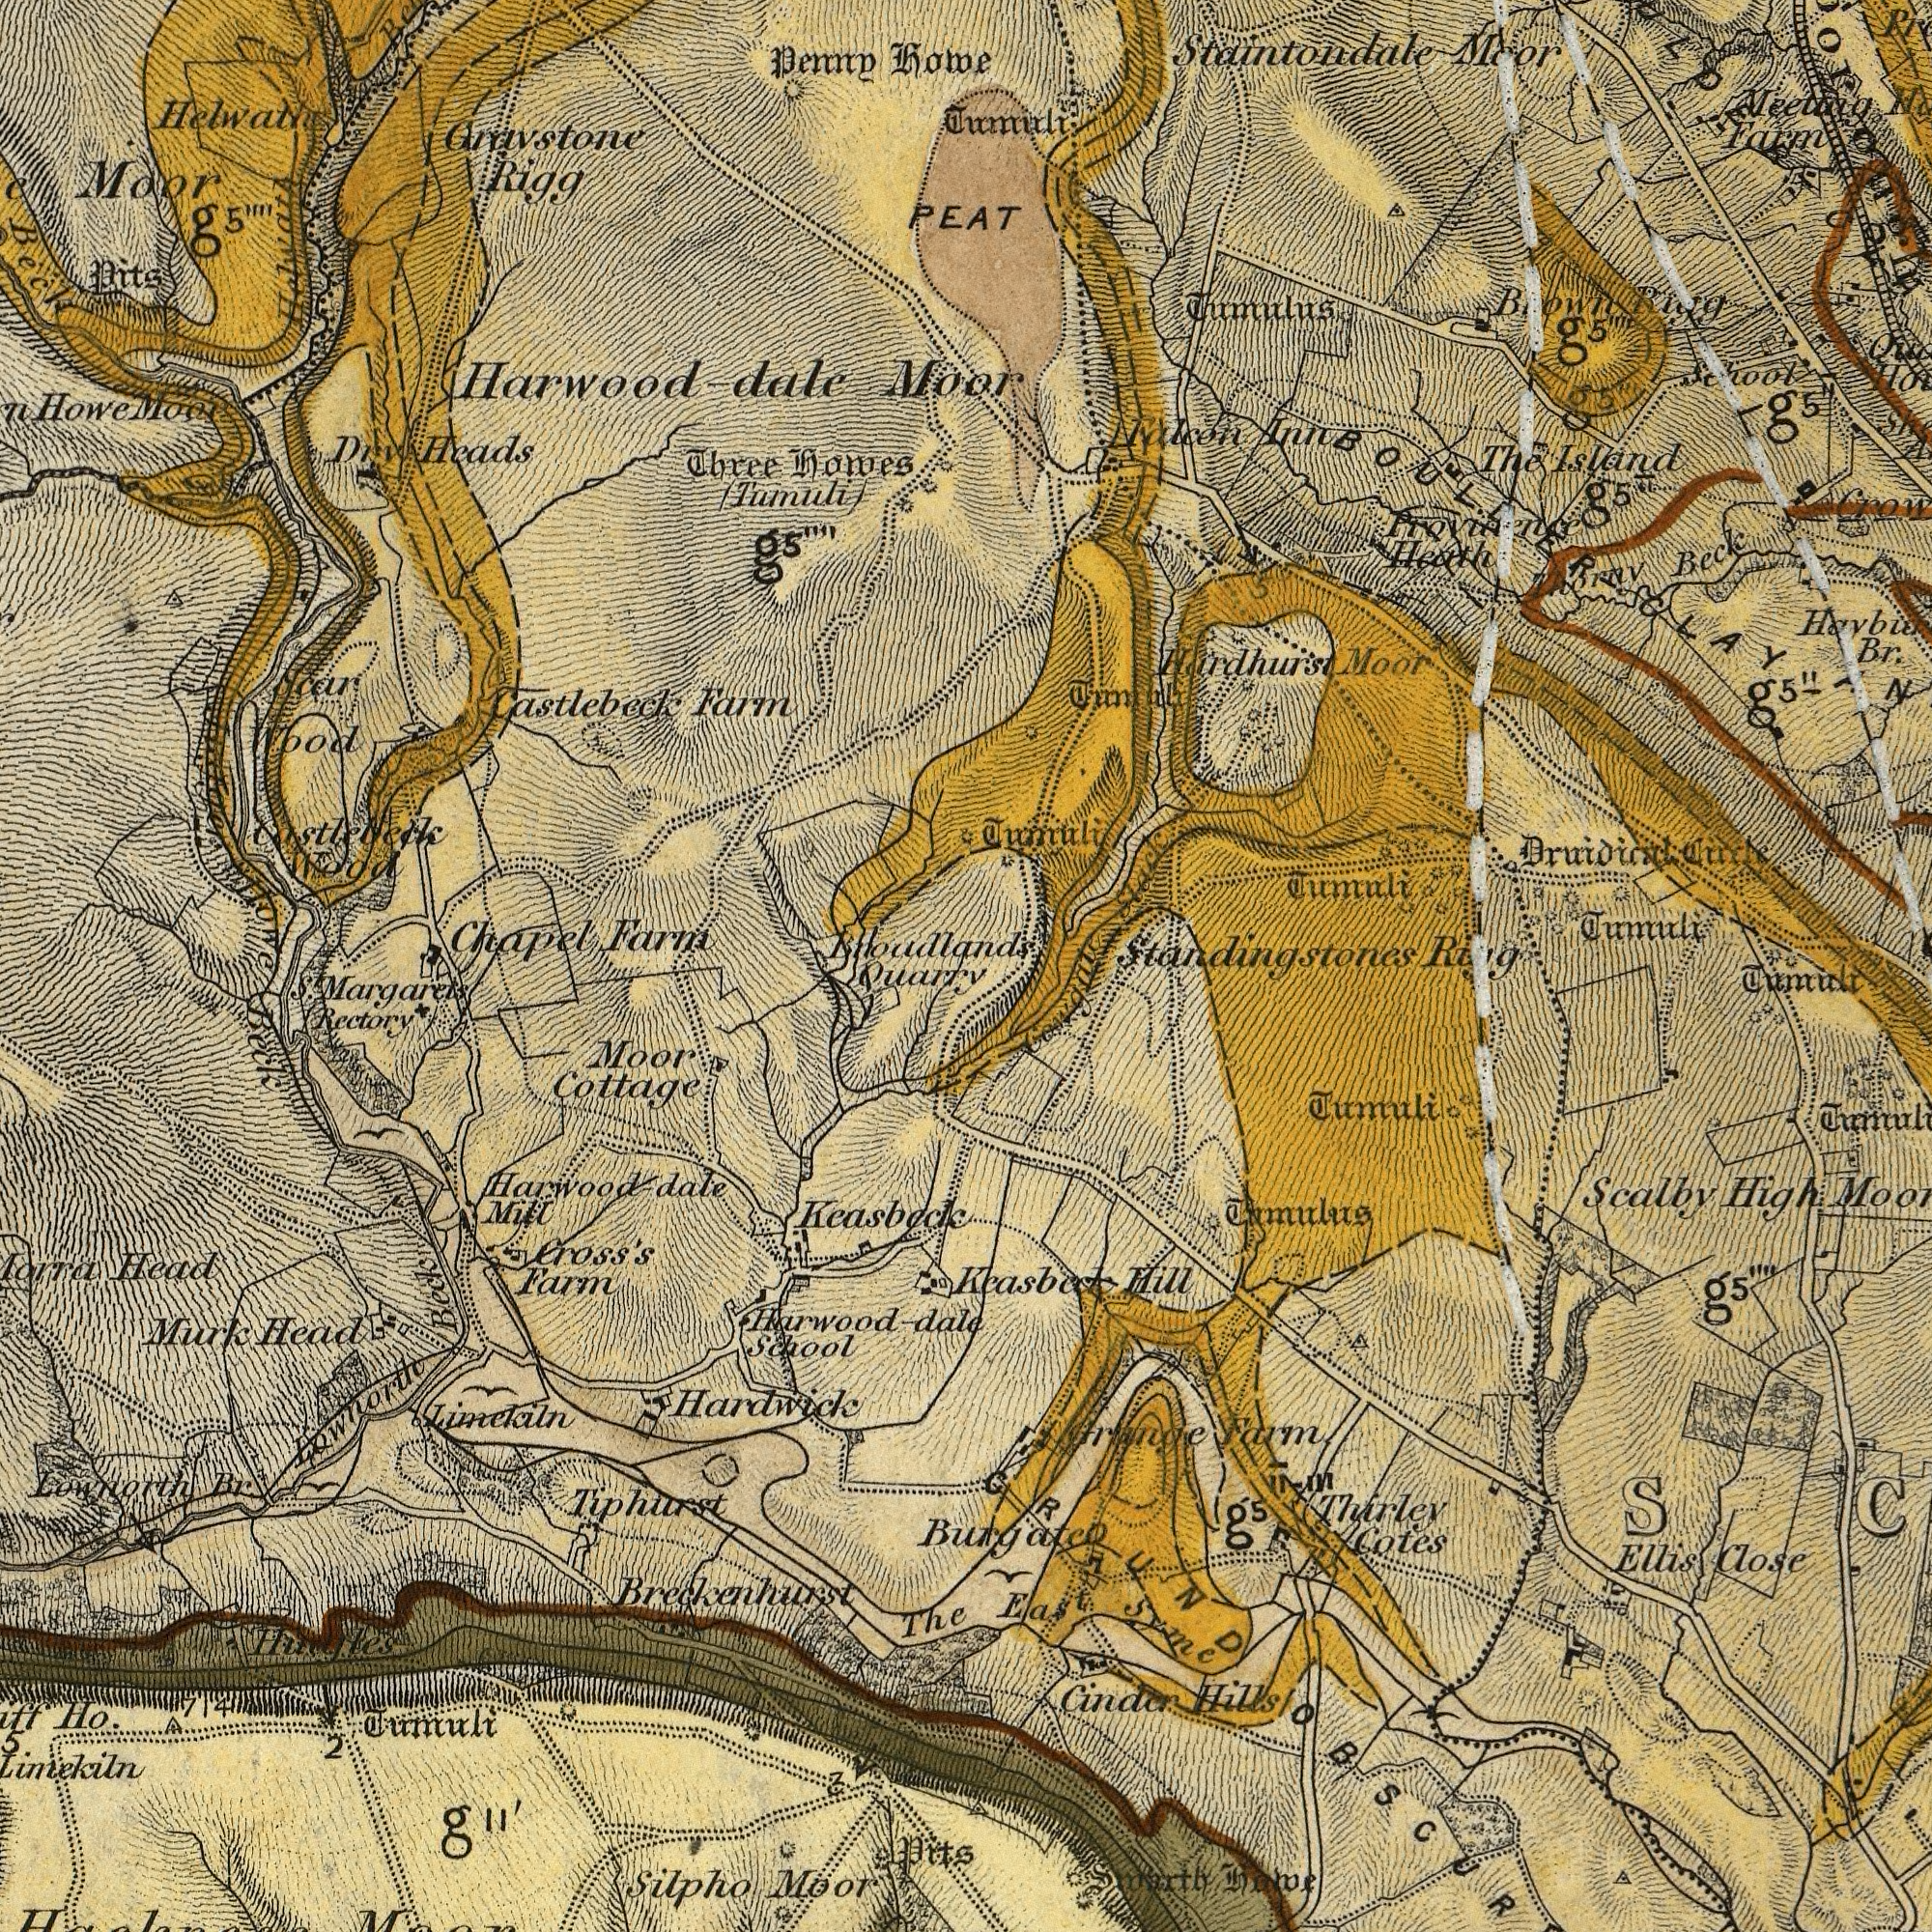What text can you see in the top-left section? Graystone Howe Moor Heads Rigg Blloadlands Farm Harwood-dale Moor (Tumuli) Penny Pits Wood Wood howes Three Beck Dry Helwath howe Chapel ###car Farm Castlebeck Castlebeck g<sup>5</sup>"" Howe g<sup>5</sup>"" Helwath Moor ###ger What text is shown in the top-right quadrant? PEAT Staintondale Farm Haybu Tumuli Moor Heath Thornv Moor Standingstones Brown Beck Tumuli Tumuli Br. The Inn Tumuli Tumulus Provinence g<sup>5</sup>" Ring Circle Rigg Hardhurst School g<sup>5</sup>"" Meeting g<sup>5</sup>" Stack Island 5 BOULDER CLAY g<sup>5</sup>" Tumuli Falcon g<sup>5</sup>"" What text appears in the bottom-right area of the image? Burgate Cinder Cotes High Tumuli Syme Thirley Ellis Farm Hill Tumulus Keasbeck Smarth Tumuli Close g<sup>5</sup>"" Orange Hills Scalby East home Gowgati GROUND g<sup>5</sup> What text is visible in the lower-left corner? Lownorth Hardwick Liniekiln Margarets Keasbeck Cottage Farm Moor Ho. Harwood-dale Moor Cross's Murk Silpho Lownorth Head Rectory School Mill The Limekiln Br. 2 Heads Beck Beck S<sup>t</sup>. g<sup>11'</sup> 3 Quarry Tiphurst Harwood-dale 5 Tumuli Breckenhurst Pits 714 